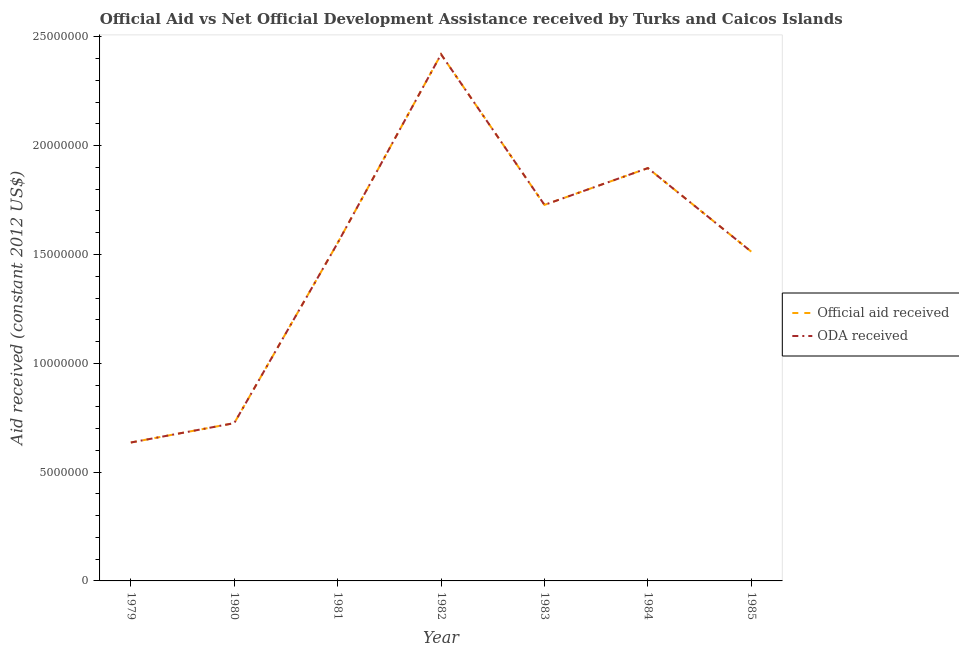How many different coloured lines are there?
Offer a very short reply. 2. Does the line corresponding to oda received intersect with the line corresponding to official aid received?
Give a very brief answer. Yes. Is the number of lines equal to the number of legend labels?
Ensure brevity in your answer.  Yes. What is the oda received in 1979?
Keep it short and to the point. 6.36e+06. Across all years, what is the maximum oda received?
Give a very brief answer. 2.42e+07. Across all years, what is the minimum official aid received?
Give a very brief answer. 6.36e+06. In which year was the official aid received maximum?
Your answer should be very brief. 1982. In which year was the official aid received minimum?
Your response must be concise. 1979. What is the total oda received in the graph?
Your response must be concise. 1.05e+08. What is the difference between the oda received in 1979 and that in 1984?
Give a very brief answer. -1.26e+07. What is the difference between the oda received in 1979 and the official aid received in 1980?
Ensure brevity in your answer.  -8.90e+05. What is the average official aid received per year?
Provide a succinct answer. 1.50e+07. In the year 1982, what is the difference between the official aid received and oda received?
Make the answer very short. 0. What is the ratio of the official aid received in 1981 to that in 1985?
Provide a succinct answer. 1.03. Is the difference between the oda received in 1983 and 1985 greater than the difference between the official aid received in 1983 and 1985?
Give a very brief answer. No. What is the difference between the highest and the second highest oda received?
Offer a terse response. 5.23e+06. What is the difference between the highest and the lowest official aid received?
Provide a succinct answer. 1.78e+07. Is the sum of the oda received in 1980 and 1984 greater than the maximum official aid received across all years?
Keep it short and to the point. Yes. Does the official aid received monotonically increase over the years?
Your answer should be very brief. No. Is the oda received strictly greater than the official aid received over the years?
Ensure brevity in your answer.  No. Is the official aid received strictly less than the oda received over the years?
Provide a succinct answer. No. How many lines are there?
Provide a succinct answer. 2. Are the values on the major ticks of Y-axis written in scientific E-notation?
Your answer should be very brief. No. Where does the legend appear in the graph?
Offer a very short reply. Center right. What is the title of the graph?
Provide a succinct answer. Official Aid vs Net Official Development Assistance received by Turks and Caicos Islands . What is the label or title of the Y-axis?
Offer a very short reply. Aid received (constant 2012 US$). What is the Aid received (constant 2012 US$) of Official aid received in 1979?
Ensure brevity in your answer.  6.36e+06. What is the Aid received (constant 2012 US$) in ODA received in 1979?
Provide a succinct answer. 6.36e+06. What is the Aid received (constant 2012 US$) of Official aid received in 1980?
Offer a terse response. 7.25e+06. What is the Aid received (constant 2012 US$) of ODA received in 1980?
Your answer should be compact. 7.25e+06. What is the Aid received (constant 2012 US$) in Official aid received in 1981?
Provide a short and direct response. 1.55e+07. What is the Aid received (constant 2012 US$) in ODA received in 1981?
Ensure brevity in your answer.  1.55e+07. What is the Aid received (constant 2012 US$) in Official aid received in 1982?
Offer a very short reply. 2.42e+07. What is the Aid received (constant 2012 US$) in ODA received in 1982?
Provide a succinct answer. 2.42e+07. What is the Aid received (constant 2012 US$) in Official aid received in 1983?
Give a very brief answer. 1.73e+07. What is the Aid received (constant 2012 US$) in ODA received in 1983?
Provide a short and direct response. 1.73e+07. What is the Aid received (constant 2012 US$) in Official aid received in 1984?
Provide a short and direct response. 1.90e+07. What is the Aid received (constant 2012 US$) of ODA received in 1984?
Provide a succinct answer. 1.90e+07. What is the Aid received (constant 2012 US$) of Official aid received in 1985?
Your answer should be very brief. 1.51e+07. What is the Aid received (constant 2012 US$) of ODA received in 1985?
Your response must be concise. 1.51e+07. Across all years, what is the maximum Aid received (constant 2012 US$) in Official aid received?
Offer a terse response. 2.42e+07. Across all years, what is the maximum Aid received (constant 2012 US$) in ODA received?
Make the answer very short. 2.42e+07. Across all years, what is the minimum Aid received (constant 2012 US$) in Official aid received?
Offer a very short reply. 6.36e+06. Across all years, what is the minimum Aid received (constant 2012 US$) in ODA received?
Make the answer very short. 6.36e+06. What is the total Aid received (constant 2012 US$) of Official aid received in the graph?
Your answer should be very brief. 1.05e+08. What is the total Aid received (constant 2012 US$) in ODA received in the graph?
Provide a succinct answer. 1.05e+08. What is the difference between the Aid received (constant 2012 US$) in Official aid received in 1979 and that in 1980?
Give a very brief answer. -8.90e+05. What is the difference between the Aid received (constant 2012 US$) of ODA received in 1979 and that in 1980?
Give a very brief answer. -8.90e+05. What is the difference between the Aid received (constant 2012 US$) of Official aid received in 1979 and that in 1981?
Your response must be concise. -9.17e+06. What is the difference between the Aid received (constant 2012 US$) of ODA received in 1979 and that in 1981?
Provide a short and direct response. -9.17e+06. What is the difference between the Aid received (constant 2012 US$) of Official aid received in 1979 and that in 1982?
Make the answer very short. -1.78e+07. What is the difference between the Aid received (constant 2012 US$) in ODA received in 1979 and that in 1982?
Offer a terse response. -1.78e+07. What is the difference between the Aid received (constant 2012 US$) of Official aid received in 1979 and that in 1983?
Give a very brief answer. -1.09e+07. What is the difference between the Aid received (constant 2012 US$) in ODA received in 1979 and that in 1983?
Give a very brief answer. -1.09e+07. What is the difference between the Aid received (constant 2012 US$) of Official aid received in 1979 and that in 1984?
Keep it short and to the point. -1.26e+07. What is the difference between the Aid received (constant 2012 US$) in ODA received in 1979 and that in 1984?
Your answer should be compact. -1.26e+07. What is the difference between the Aid received (constant 2012 US$) of Official aid received in 1979 and that in 1985?
Provide a short and direct response. -8.77e+06. What is the difference between the Aid received (constant 2012 US$) of ODA received in 1979 and that in 1985?
Your answer should be compact. -8.77e+06. What is the difference between the Aid received (constant 2012 US$) of Official aid received in 1980 and that in 1981?
Keep it short and to the point. -8.28e+06. What is the difference between the Aid received (constant 2012 US$) in ODA received in 1980 and that in 1981?
Your answer should be very brief. -8.28e+06. What is the difference between the Aid received (constant 2012 US$) of Official aid received in 1980 and that in 1982?
Offer a very short reply. -1.70e+07. What is the difference between the Aid received (constant 2012 US$) of ODA received in 1980 and that in 1982?
Provide a short and direct response. -1.70e+07. What is the difference between the Aid received (constant 2012 US$) in Official aid received in 1980 and that in 1983?
Offer a terse response. -1.00e+07. What is the difference between the Aid received (constant 2012 US$) of ODA received in 1980 and that in 1983?
Your answer should be very brief. -1.00e+07. What is the difference between the Aid received (constant 2012 US$) in Official aid received in 1980 and that in 1984?
Your answer should be very brief. -1.17e+07. What is the difference between the Aid received (constant 2012 US$) of ODA received in 1980 and that in 1984?
Ensure brevity in your answer.  -1.17e+07. What is the difference between the Aid received (constant 2012 US$) of Official aid received in 1980 and that in 1985?
Offer a very short reply. -7.88e+06. What is the difference between the Aid received (constant 2012 US$) of ODA received in 1980 and that in 1985?
Provide a short and direct response. -7.88e+06. What is the difference between the Aid received (constant 2012 US$) in Official aid received in 1981 and that in 1982?
Offer a terse response. -8.67e+06. What is the difference between the Aid received (constant 2012 US$) of ODA received in 1981 and that in 1982?
Provide a short and direct response. -8.67e+06. What is the difference between the Aid received (constant 2012 US$) in Official aid received in 1981 and that in 1983?
Keep it short and to the point. -1.75e+06. What is the difference between the Aid received (constant 2012 US$) in ODA received in 1981 and that in 1983?
Your answer should be very brief. -1.75e+06. What is the difference between the Aid received (constant 2012 US$) in Official aid received in 1981 and that in 1984?
Give a very brief answer. -3.44e+06. What is the difference between the Aid received (constant 2012 US$) of ODA received in 1981 and that in 1984?
Provide a short and direct response. -3.44e+06. What is the difference between the Aid received (constant 2012 US$) of Official aid received in 1981 and that in 1985?
Your response must be concise. 4.00e+05. What is the difference between the Aid received (constant 2012 US$) of Official aid received in 1982 and that in 1983?
Provide a short and direct response. 6.92e+06. What is the difference between the Aid received (constant 2012 US$) of ODA received in 1982 and that in 1983?
Keep it short and to the point. 6.92e+06. What is the difference between the Aid received (constant 2012 US$) in Official aid received in 1982 and that in 1984?
Provide a short and direct response. 5.23e+06. What is the difference between the Aid received (constant 2012 US$) in ODA received in 1982 and that in 1984?
Offer a terse response. 5.23e+06. What is the difference between the Aid received (constant 2012 US$) in Official aid received in 1982 and that in 1985?
Ensure brevity in your answer.  9.07e+06. What is the difference between the Aid received (constant 2012 US$) of ODA received in 1982 and that in 1985?
Ensure brevity in your answer.  9.07e+06. What is the difference between the Aid received (constant 2012 US$) in Official aid received in 1983 and that in 1984?
Provide a short and direct response. -1.69e+06. What is the difference between the Aid received (constant 2012 US$) of ODA received in 1983 and that in 1984?
Provide a short and direct response. -1.69e+06. What is the difference between the Aid received (constant 2012 US$) of Official aid received in 1983 and that in 1985?
Keep it short and to the point. 2.15e+06. What is the difference between the Aid received (constant 2012 US$) of ODA received in 1983 and that in 1985?
Your answer should be compact. 2.15e+06. What is the difference between the Aid received (constant 2012 US$) in Official aid received in 1984 and that in 1985?
Give a very brief answer. 3.84e+06. What is the difference between the Aid received (constant 2012 US$) of ODA received in 1984 and that in 1985?
Make the answer very short. 3.84e+06. What is the difference between the Aid received (constant 2012 US$) in Official aid received in 1979 and the Aid received (constant 2012 US$) in ODA received in 1980?
Keep it short and to the point. -8.90e+05. What is the difference between the Aid received (constant 2012 US$) in Official aid received in 1979 and the Aid received (constant 2012 US$) in ODA received in 1981?
Your answer should be compact. -9.17e+06. What is the difference between the Aid received (constant 2012 US$) in Official aid received in 1979 and the Aid received (constant 2012 US$) in ODA received in 1982?
Provide a succinct answer. -1.78e+07. What is the difference between the Aid received (constant 2012 US$) in Official aid received in 1979 and the Aid received (constant 2012 US$) in ODA received in 1983?
Your response must be concise. -1.09e+07. What is the difference between the Aid received (constant 2012 US$) of Official aid received in 1979 and the Aid received (constant 2012 US$) of ODA received in 1984?
Provide a short and direct response. -1.26e+07. What is the difference between the Aid received (constant 2012 US$) in Official aid received in 1979 and the Aid received (constant 2012 US$) in ODA received in 1985?
Provide a short and direct response. -8.77e+06. What is the difference between the Aid received (constant 2012 US$) of Official aid received in 1980 and the Aid received (constant 2012 US$) of ODA received in 1981?
Make the answer very short. -8.28e+06. What is the difference between the Aid received (constant 2012 US$) of Official aid received in 1980 and the Aid received (constant 2012 US$) of ODA received in 1982?
Provide a succinct answer. -1.70e+07. What is the difference between the Aid received (constant 2012 US$) of Official aid received in 1980 and the Aid received (constant 2012 US$) of ODA received in 1983?
Make the answer very short. -1.00e+07. What is the difference between the Aid received (constant 2012 US$) of Official aid received in 1980 and the Aid received (constant 2012 US$) of ODA received in 1984?
Offer a very short reply. -1.17e+07. What is the difference between the Aid received (constant 2012 US$) in Official aid received in 1980 and the Aid received (constant 2012 US$) in ODA received in 1985?
Your response must be concise. -7.88e+06. What is the difference between the Aid received (constant 2012 US$) of Official aid received in 1981 and the Aid received (constant 2012 US$) of ODA received in 1982?
Offer a terse response. -8.67e+06. What is the difference between the Aid received (constant 2012 US$) in Official aid received in 1981 and the Aid received (constant 2012 US$) in ODA received in 1983?
Your answer should be very brief. -1.75e+06. What is the difference between the Aid received (constant 2012 US$) of Official aid received in 1981 and the Aid received (constant 2012 US$) of ODA received in 1984?
Provide a short and direct response. -3.44e+06. What is the difference between the Aid received (constant 2012 US$) of Official aid received in 1982 and the Aid received (constant 2012 US$) of ODA received in 1983?
Ensure brevity in your answer.  6.92e+06. What is the difference between the Aid received (constant 2012 US$) in Official aid received in 1982 and the Aid received (constant 2012 US$) in ODA received in 1984?
Offer a terse response. 5.23e+06. What is the difference between the Aid received (constant 2012 US$) of Official aid received in 1982 and the Aid received (constant 2012 US$) of ODA received in 1985?
Your response must be concise. 9.07e+06. What is the difference between the Aid received (constant 2012 US$) in Official aid received in 1983 and the Aid received (constant 2012 US$) in ODA received in 1984?
Ensure brevity in your answer.  -1.69e+06. What is the difference between the Aid received (constant 2012 US$) of Official aid received in 1983 and the Aid received (constant 2012 US$) of ODA received in 1985?
Give a very brief answer. 2.15e+06. What is the difference between the Aid received (constant 2012 US$) of Official aid received in 1984 and the Aid received (constant 2012 US$) of ODA received in 1985?
Your answer should be very brief. 3.84e+06. What is the average Aid received (constant 2012 US$) in Official aid received per year?
Ensure brevity in your answer.  1.50e+07. What is the average Aid received (constant 2012 US$) in ODA received per year?
Offer a terse response. 1.50e+07. In the year 1980, what is the difference between the Aid received (constant 2012 US$) of Official aid received and Aid received (constant 2012 US$) of ODA received?
Provide a succinct answer. 0. In the year 1981, what is the difference between the Aid received (constant 2012 US$) of Official aid received and Aid received (constant 2012 US$) of ODA received?
Your response must be concise. 0. In the year 1983, what is the difference between the Aid received (constant 2012 US$) of Official aid received and Aid received (constant 2012 US$) of ODA received?
Keep it short and to the point. 0. In the year 1985, what is the difference between the Aid received (constant 2012 US$) in Official aid received and Aid received (constant 2012 US$) in ODA received?
Offer a terse response. 0. What is the ratio of the Aid received (constant 2012 US$) in Official aid received in 1979 to that in 1980?
Ensure brevity in your answer.  0.88. What is the ratio of the Aid received (constant 2012 US$) in ODA received in 1979 to that in 1980?
Keep it short and to the point. 0.88. What is the ratio of the Aid received (constant 2012 US$) in Official aid received in 1979 to that in 1981?
Offer a very short reply. 0.41. What is the ratio of the Aid received (constant 2012 US$) in ODA received in 1979 to that in 1981?
Offer a terse response. 0.41. What is the ratio of the Aid received (constant 2012 US$) in Official aid received in 1979 to that in 1982?
Make the answer very short. 0.26. What is the ratio of the Aid received (constant 2012 US$) in ODA received in 1979 to that in 1982?
Your response must be concise. 0.26. What is the ratio of the Aid received (constant 2012 US$) of Official aid received in 1979 to that in 1983?
Your answer should be very brief. 0.37. What is the ratio of the Aid received (constant 2012 US$) of ODA received in 1979 to that in 1983?
Your response must be concise. 0.37. What is the ratio of the Aid received (constant 2012 US$) of Official aid received in 1979 to that in 1984?
Your answer should be compact. 0.34. What is the ratio of the Aid received (constant 2012 US$) in ODA received in 1979 to that in 1984?
Make the answer very short. 0.34. What is the ratio of the Aid received (constant 2012 US$) of Official aid received in 1979 to that in 1985?
Provide a succinct answer. 0.42. What is the ratio of the Aid received (constant 2012 US$) of ODA received in 1979 to that in 1985?
Your response must be concise. 0.42. What is the ratio of the Aid received (constant 2012 US$) in Official aid received in 1980 to that in 1981?
Ensure brevity in your answer.  0.47. What is the ratio of the Aid received (constant 2012 US$) of ODA received in 1980 to that in 1981?
Your answer should be very brief. 0.47. What is the ratio of the Aid received (constant 2012 US$) in Official aid received in 1980 to that in 1982?
Offer a very short reply. 0.3. What is the ratio of the Aid received (constant 2012 US$) of ODA received in 1980 to that in 1982?
Provide a succinct answer. 0.3. What is the ratio of the Aid received (constant 2012 US$) of Official aid received in 1980 to that in 1983?
Keep it short and to the point. 0.42. What is the ratio of the Aid received (constant 2012 US$) of ODA received in 1980 to that in 1983?
Offer a terse response. 0.42. What is the ratio of the Aid received (constant 2012 US$) in Official aid received in 1980 to that in 1984?
Give a very brief answer. 0.38. What is the ratio of the Aid received (constant 2012 US$) of ODA received in 1980 to that in 1984?
Offer a very short reply. 0.38. What is the ratio of the Aid received (constant 2012 US$) of Official aid received in 1980 to that in 1985?
Your response must be concise. 0.48. What is the ratio of the Aid received (constant 2012 US$) in ODA received in 1980 to that in 1985?
Provide a succinct answer. 0.48. What is the ratio of the Aid received (constant 2012 US$) in Official aid received in 1981 to that in 1982?
Ensure brevity in your answer.  0.64. What is the ratio of the Aid received (constant 2012 US$) of ODA received in 1981 to that in 1982?
Your response must be concise. 0.64. What is the ratio of the Aid received (constant 2012 US$) in Official aid received in 1981 to that in 1983?
Provide a succinct answer. 0.9. What is the ratio of the Aid received (constant 2012 US$) in ODA received in 1981 to that in 1983?
Your answer should be very brief. 0.9. What is the ratio of the Aid received (constant 2012 US$) of Official aid received in 1981 to that in 1984?
Your response must be concise. 0.82. What is the ratio of the Aid received (constant 2012 US$) in ODA received in 1981 to that in 1984?
Give a very brief answer. 0.82. What is the ratio of the Aid received (constant 2012 US$) in Official aid received in 1981 to that in 1985?
Keep it short and to the point. 1.03. What is the ratio of the Aid received (constant 2012 US$) in ODA received in 1981 to that in 1985?
Your response must be concise. 1.03. What is the ratio of the Aid received (constant 2012 US$) of Official aid received in 1982 to that in 1983?
Your answer should be very brief. 1.4. What is the ratio of the Aid received (constant 2012 US$) of ODA received in 1982 to that in 1983?
Your answer should be compact. 1.4. What is the ratio of the Aid received (constant 2012 US$) of Official aid received in 1982 to that in 1984?
Your response must be concise. 1.28. What is the ratio of the Aid received (constant 2012 US$) in ODA received in 1982 to that in 1984?
Give a very brief answer. 1.28. What is the ratio of the Aid received (constant 2012 US$) in Official aid received in 1982 to that in 1985?
Your answer should be compact. 1.6. What is the ratio of the Aid received (constant 2012 US$) of ODA received in 1982 to that in 1985?
Your response must be concise. 1.6. What is the ratio of the Aid received (constant 2012 US$) in Official aid received in 1983 to that in 1984?
Offer a very short reply. 0.91. What is the ratio of the Aid received (constant 2012 US$) of ODA received in 1983 to that in 1984?
Keep it short and to the point. 0.91. What is the ratio of the Aid received (constant 2012 US$) in Official aid received in 1983 to that in 1985?
Provide a succinct answer. 1.14. What is the ratio of the Aid received (constant 2012 US$) of ODA received in 1983 to that in 1985?
Offer a terse response. 1.14. What is the ratio of the Aid received (constant 2012 US$) of Official aid received in 1984 to that in 1985?
Your answer should be very brief. 1.25. What is the ratio of the Aid received (constant 2012 US$) of ODA received in 1984 to that in 1985?
Your response must be concise. 1.25. What is the difference between the highest and the second highest Aid received (constant 2012 US$) of Official aid received?
Offer a very short reply. 5.23e+06. What is the difference between the highest and the second highest Aid received (constant 2012 US$) of ODA received?
Your answer should be compact. 5.23e+06. What is the difference between the highest and the lowest Aid received (constant 2012 US$) in Official aid received?
Make the answer very short. 1.78e+07. What is the difference between the highest and the lowest Aid received (constant 2012 US$) of ODA received?
Your response must be concise. 1.78e+07. 